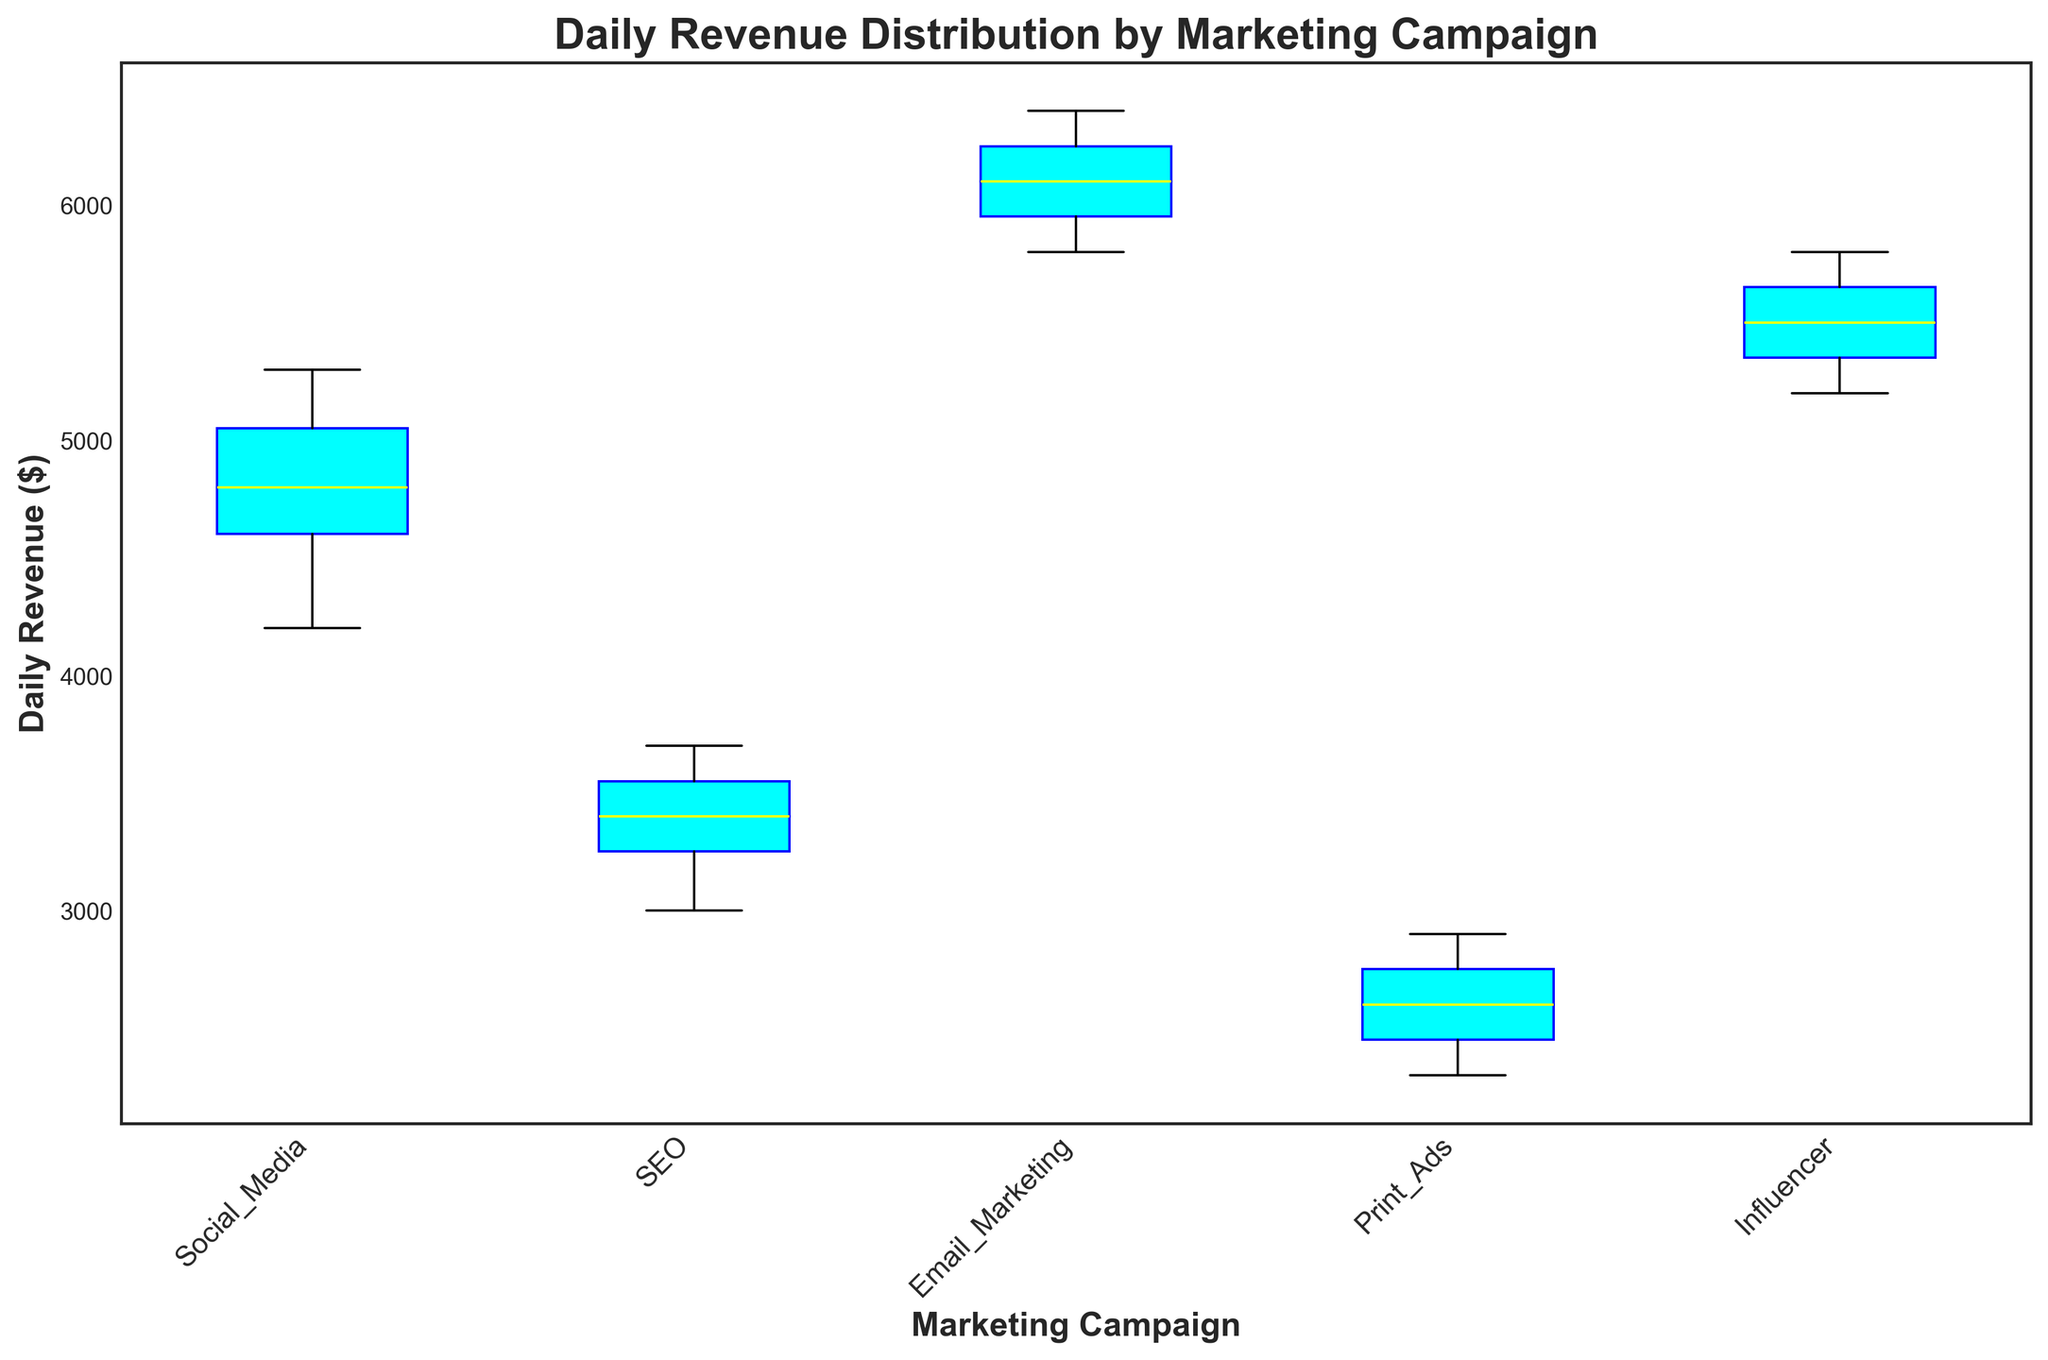Which marketing campaign has the highest median daily revenue? By looking at the box plot, the median value is marked by the yellow line inside each box. The campaign with the yellow line positioned highest on the vertical axis has the highest median daily revenue.
Answer: Email Marketing What's the interquartile range (IQR) for the Social Media campaign? The IQR is the range between the first quartile (Q1, lower edge of the box) and the third quartile (Q3, upper edge of the box). Measure the vertical distance between the lower and upper edges of the box for the Social Media campaign to determine the IQR.
Answer: 900 Which campaign shows the highest variability in daily revenue? The campaign with the widest box plot (the range between the bottom and top of the box) has the highest variability, as this indicates a larger interquartile range.
Answer: Social Media Is the daily revenue for the Email Marketing campaign more than the Influencer campaign on average? By comparing the median values (indicated by yellow lines) for both campaigns, observe that the Email Marketing median is higher than the Influencer campaign’s median.
Answer: Yes Which campaign's revenue distribution is the most symmetrical? Look for the box where the median line (yellow) is approximately centered within the box and the whiskers are about equal length. The more symmetrical distribution will have these attributes.
Answer: SEO Between Print Ads and SEO, which campaign has lower overall revenue? Compare the position of the whiskers and the boxes; the campaign with the lower positioned box and whiskers on the vertical axis has lower overall revenue.
Answer: Print Ads Is there any campaign with outliers, and if so, which ones? Check for red markers outside the whiskers. If present, those indicate outliers.
Answer: None What is the approximate range of daily revenue for the Influencer campaign? Calculate the difference between the top and bottom whiskers of the Influencer campaign’s box plot to determine the range.
Answer: 600 Among all campaigns, which one has the lowest median daily revenue? Identify the campaign with the lowest yellow line inside the box plot.
Answer: Print Ads 